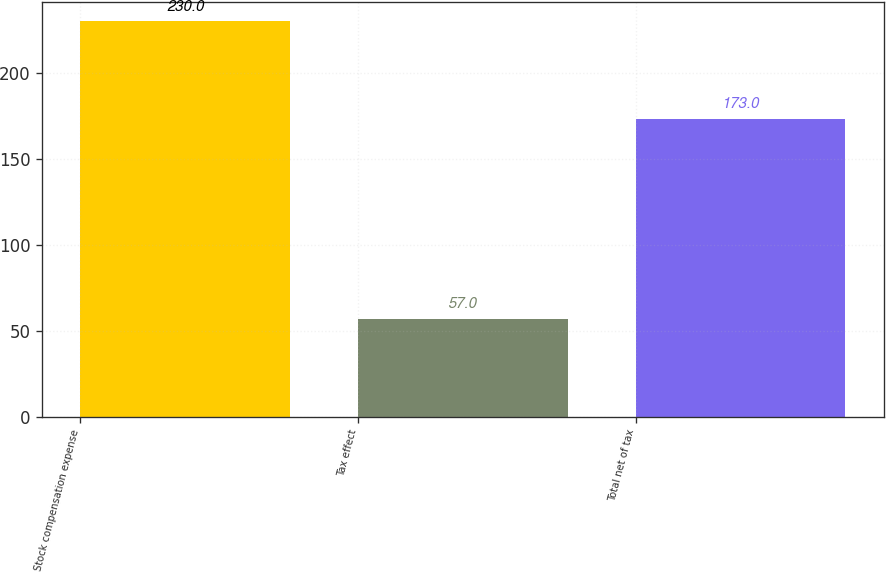Convert chart to OTSL. <chart><loc_0><loc_0><loc_500><loc_500><bar_chart><fcel>Stock compensation expense<fcel>Tax effect<fcel>Total net of tax<nl><fcel>230<fcel>57<fcel>173<nl></chart> 